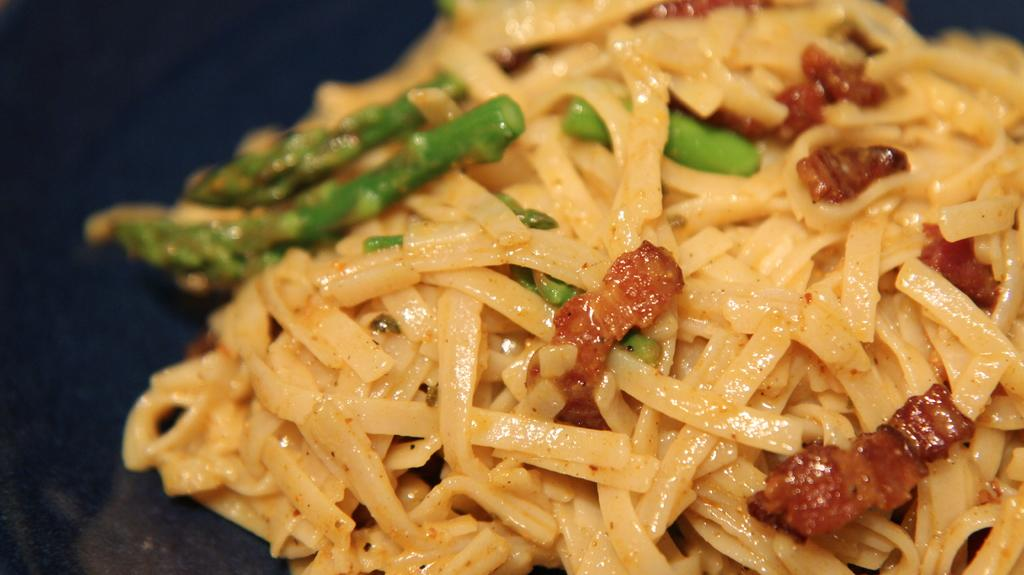What is present in the image? There is food in the image. Where is the food located? The food is placed on a surface. What hobbies do the mice in the image enjoy? There are no mice present in the image, so we cannot determine their hobbies. 